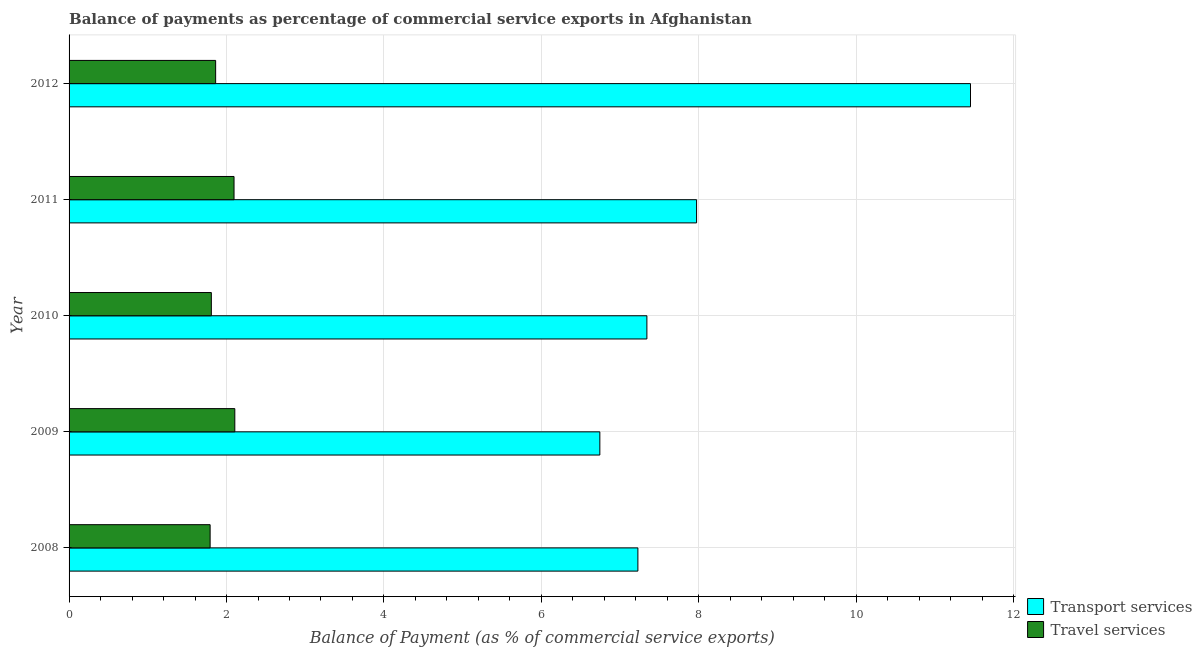How many different coloured bars are there?
Keep it short and to the point. 2. Are the number of bars per tick equal to the number of legend labels?
Provide a succinct answer. Yes. Are the number of bars on each tick of the Y-axis equal?
Provide a succinct answer. Yes. How many bars are there on the 3rd tick from the top?
Your response must be concise. 2. How many bars are there on the 1st tick from the bottom?
Your response must be concise. 2. In how many cases, is the number of bars for a given year not equal to the number of legend labels?
Offer a terse response. 0. What is the balance of payments of travel services in 2008?
Keep it short and to the point. 1.79. Across all years, what is the maximum balance of payments of transport services?
Ensure brevity in your answer.  11.45. Across all years, what is the minimum balance of payments of travel services?
Offer a very short reply. 1.79. In which year was the balance of payments of travel services maximum?
Your answer should be very brief. 2009. What is the total balance of payments of transport services in the graph?
Ensure brevity in your answer.  40.73. What is the difference between the balance of payments of travel services in 2010 and that in 2012?
Give a very brief answer. -0.06. What is the difference between the balance of payments of transport services in 2011 and the balance of payments of travel services in 2008?
Offer a very short reply. 6.18. What is the average balance of payments of travel services per year?
Provide a short and direct response. 1.93. In the year 2008, what is the difference between the balance of payments of travel services and balance of payments of transport services?
Your response must be concise. -5.43. In how many years, is the balance of payments of transport services greater than 5.2 %?
Your answer should be very brief. 5. What is the ratio of the balance of payments of transport services in 2009 to that in 2012?
Offer a very short reply. 0.59. What is the difference between the highest and the second highest balance of payments of transport services?
Offer a terse response. 3.48. What is the difference between the highest and the lowest balance of payments of travel services?
Ensure brevity in your answer.  0.31. What does the 2nd bar from the top in 2008 represents?
Give a very brief answer. Transport services. What does the 1st bar from the bottom in 2008 represents?
Offer a very short reply. Transport services. How many years are there in the graph?
Ensure brevity in your answer.  5. How are the legend labels stacked?
Your answer should be compact. Vertical. What is the title of the graph?
Offer a terse response. Balance of payments as percentage of commercial service exports in Afghanistan. What is the label or title of the X-axis?
Keep it short and to the point. Balance of Payment (as % of commercial service exports). What is the Balance of Payment (as % of commercial service exports) in Transport services in 2008?
Ensure brevity in your answer.  7.23. What is the Balance of Payment (as % of commercial service exports) in Travel services in 2008?
Provide a short and direct response. 1.79. What is the Balance of Payment (as % of commercial service exports) in Transport services in 2009?
Offer a very short reply. 6.74. What is the Balance of Payment (as % of commercial service exports) in Travel services in 2009?
Make the answer very short. 2.11. What is the Balance of Payment (as % of commercial service exports) of Transport services in 2010?
Provide a succinct answer. 7.34. What is the Balance of Payment (as % of commercial service exports) in Travel services in 2010?
Offer a very short reply. 1.81. What is the Balance of Payment (as % of commercial service exports) in Transport services in 2011?
Ensure brevity in your answer.  7.97. What is the Balance of Payment (as % of commercial service exports) of Travel services in 2011?
Ensure brevity in your answer.  2.1. What is the Balance of Payment (as % of commercial service exports) in Transport services in 2012?
Your answer should be compact. 11.45. What is the Balance of Payment (as % of commercial service exports) in Travel services in 2012?
Keep it short and to the point. 1.86. Across all years, what is the maximum Balance of Payment (as % of commercial service exports) in Transport services?
Provide a succinct answer. 11.45. Across all years, what is the maximum Balance of Payment (as % of commercial service exports) of Travel services?
Offer a terse response. 2.11. Across all years, what is the minimum Balance of Payment (as % of commercial service exports) of Transport services?
Ensure brevity in your answer.  6.74. Across all years, what is the minimum Balance of Payment (as % of commercial service exports) in Travel services?
Provide a short and direct response. 1.79. What is the total Balance of Payment (as % of commercial service exports) of Transport services in the graph?
Your answer should be very brief. 40.73. What is the total Balance of Payment (as % of commercial service exports) of Travel services in the graph?
Keep it short and to the point. 9.66. What is the difference between the Balance of Payment (as % of commercial service exports) of Transport services in 2008 and that in 2009?
Ensure brevity in your answer.  0.48. What is the difference between the Balance of Payment (as % of commercial service exports) in Travel services in 2008 and that in 2009?
Offer a terse response. -0.31. What is the difference between the Balance of Payment (as % of commercial service exports) of Transport services in 2008 and that in 2010?
Give a very brief answer. -0.11. What is the difference between the Balance of Payment (as % of commercial service exports) in Travel services in 2008 and that in 2010?
Your answer should be compact. -0.02. What is the difference between the Balance of Payment (as % of commercial service exports) in Transport services in 2008 and that in 2011?
Ensure brevity in your answer.  -0.75. What is the difference between the Balance of Payment (as % of commercial service exports) of Travel services in 2008 and that in 2011?
Provide a short and direct response. -0.3. What is the difference between the Balance of Payment (as % of commercial service exports) in Transport services in 2008 and that in 2012?
Provide a short and direct response. -4.23. What is the difference between the Balance of Payment (as % of commercial service exports) of Travel services in 2008 and that in 2012?
Provide a short and direct response. -0.07. What is the difference between the Balance of Payment (as % of commercial service exports) of Transport services in 2009 and that in 2010?
Your answer should be very brief. -0.6. What is the difference between the Balance of Payment (as % of commercial service exports) in Travel services in 2009 and that in 2010?
Your answer should be very brief. 0.3. What is the difference between the Balance of Payment (as % of commercial service exports) in Transport services in 2009 and that in 2011?
Offer a terse response. -1.23. What is the difference between the Balance of Payment (as % of commercial service exports) of Travel services in 2009 and that in 2011?
Make the answer very short. 0.01. What is the difference between the Balance of Payment (as % of commercial service exports) in Transport services in 2009 and that in 2012?
Your answer should be very brief. -4.71. What is the difference between the Balance of Payment (as % of commercial service exports) of Travel services in 2009 and that in 2012?
Give a very brief answer. 0.24. What is the difference between the Balance of Payment (as % of commercial service exports) in Transport services in 2010 and that in 2011?
Make the answer very short. -0.63. What is the difference between the Balance of Payment (as % of commercial service exports) of Travel services in 2010 and that in 2011?
Offer a very short reply. -0.29. What is the difference between the Balance of Payment (as % of commercial service exports) in Transport services in 2010 and that in 2012?
Your answer should be compact. -4.11. What is the difference between the Balance of Payment (as % of commercial service exports) of Travel services in 2010 and that in 2012?
Your answer should be very brief. -0.05. What is the difference between the Balance of Payment (as % of commercial service exports) of Transport services in 2011 and that in 2012?
Offer a very short reply. -3.48. What is the difference between the Balance of Payment (as % of commercial service exports) in Travel services in 2011 and that in 2012?
Provide a short and direct response. 0.23. What is the difference between the Balance of Payment (as % of commercial service exports) in Transport services in 2008 and the Balance of Payment (as % of commercial service exports) in Travel services in 2009?
Make the answer very short. 5.12. What is the difference between the Balance of Payment (as % of commercial service exports) of Transport services in 2008 and the Balance of Payment (as % of commercial service exports) of Travel services in 2010?
Your answer should be compact. 5.42. What is the difference between the Balance of Payment (as % of commercial service exports) in Transport services in 2008 and the Balance of Payment (as % of commercial service exports) in Travel services in 2011?
Offer a very short reply. 5.13. What is the difference between the Balance of Payment (as % of commercial service exports) in Transport services in 2008 and the Balance of Payment (as % of commercial service exports) in Travel services in 2012?
Provide a succinct answer. 5.36. What is the difference between the Balance of Payment (as % of commercial service exports) in Transport services in 2009 and the Balance of Payment (as % of commercial service exports) in Travel services in 2010?
Your answer should be compact. 4.93. What is the difference between the Balance of Payment (as % of commercial service exports) in Transport services in 2009 and the Balance of Payment (as % of commercial service exports) in Travel services in 2011?
Make the answer very short. 4.65. What is the difference between the Balance of Payment (as % of commercial service exports) in Transport services in 2009 and the Balance of Payment (as % of commercial service exports) in Travel services in 2012?
Keep it short and to the point. 4.88. What is the difference between the Balance of Payment (as % of commercial service exports) of Transport services in 2010 and the Balance of Payment (as % of commercial service exports) of Travel services in 2011?
Your answer should be very brief. 5.24. What is the difference between the Balance of Payment (as % of commercial service exports) in Transport services in 2010 and the Balance of Payment (as % of commercial service exports) in Travel services in 2012?
Keep it short and to the point. 5.48. What is the difference between the Balance of Payment (as % of commercial service exports) of Transport services in 2011 and the Balance of Payment (as % of commercial service exports) of Travel services in 2012?
Offer a terse response. 6.11. What is the average Balance of Payment (as % of commercial service exports) in Transport services per year?
Your answer should be very brief. 8.15. What is the average Balance of Payment (as % of commercial service exports) of Travel services per year?
Ensure brevity in your answer.  1.93. In the year 2008, what is the difference between the Balance of Payment (as % of commercial service exports) of Transport services and Balance of Payment (as % of commercial service exports) of Travel services?
Offer a very short reply. 5.43. In the year 2009, what is the difference between the Balance of Payment (as % of commercial service exports) in Transport services and Balance of Payment (as % of commercial service exports) in Travel services?
Keep it short and to the point. 4.64. In the year 2010, what is the difference between the Balance of Payment (as % of commercial service exports) in Transport services and Balance of Payment (as % of commercial service exports) in Travel services?
Ensure brevity in your answer.  5.53. In the year 2011, what is the difference between the Balance of Payment (as % of commercial service exports) in Transport services and Balance of Payment (as % of commercial service exports) in Travel services?
Offer a terse response. 5.88. In the year 2012, what is the difference between the Balance of Payment (as % of commercial service exports) in Transport services and Balance of Payment (as % of commercial service exports) in Travel services?
Give a very brief answer. 9.59. What is the ratio of the Balance of Payment (as % of commercial service exports) of Transport services in 2008 to that in 2009?
Your answer should be very brief. 1.07. What is the ratio of the Balance of Payment (as % of commercial service exports) of Travel services in 2008 to that in 2009?
Your response must be concise. 0.85. What is the ratio of the Balance of Payment (as % of commercial service exports) of Transport services in 2008 to that in 2010?
Keep it short and to the point. 0.98. What is the ratio of the Balance of Payment (as % of commercial service exports) of Travel services in 2008 to that in 2010?
Provide a short and direct response. 0.99. What is the ratio of the Balance of Payment (as % of commercial service exports) of Transport services in 2008 to that in 2011?
Keep it short and to the point. 0.91. What is the ratio of the Balance of Payment (as % of commercial service exports) of Travel services in 2008 to that in 2011?
Give a very brief answer. 0.86. What is the ratio of the Balance of Payment (as % of commercial service exports) in Transport services in 2008 to that in 2012?
Give a very brief answer. 0.63. What is the ratio of the Balance of Payment (as % of commercial service exports) of Travel services in 2008 to that in 2012?
Make the answer very short. 0.96. What is the ratio of the Balance of Payment (as % of commercial service exports) of Transport services in 2009 to that in 2010?
Make the answer very short. 0.92. What is the ratio of the Balance of Payment (as % of commercial service exports) of Travel services in 2009 to that in 2010?
Offer a very short reply. 1.16. What is the ratio of the Balance of Payment (as % of commercial service exports) in Transport services in 2009 to that in 2011?
Provide a short and direct response. 0.85. What is the ratio of the Balance of Payment (as % of commercial service exports) in Travel services in 2009 to that in 2011?
Your answer should be compact. 1. What is the ratio of the Balance of Payment (as % of commercial service exports) of Transport services in 2009 to that in 2012?
Your answer should be compact. 0.59. What is the ratio of the Balance of Payment (as % of commercial service exports) of Travel services in 2009 to that in 2012?
Keep it short and to the point. 1.13. What is the ratio of the Balance of Payment (as % of commercial service exports) in Transport services in 2010 to that in 2011?
Give a very brief answer. 0.92. What is the ratio of the Balance of Payment (as % of commercial service exports) in Travel services in 2010 to that in 2011?
Offer a very short reply. 0.86. What is the ratio of the Balance of Payment (as % of commercial service exports) in Transport services in 2010 to that in 2012?
Offer a terse response. 0.64. What is the ratio of the Balance of Payment (as % of commercial service exports) of Travel services in 2010 to that in 2012?
Your answer should be compact. 0.97. What is the ratio of the Balance of Payment (as % of commercial service exports) in Transport services in 2011 to that in 2012?
Keep it short and to the point. 0.7. What is the ratio of the Balance of Payment (as % of commercial service exports) in Travel services in 2011 to that in 2012?
Provide a short and direct response. 1.13. What is the difference between the highest and the second highest Balance of Payment (as % of commercial service exports) of Transport services?
Make the answer very short. 3.48. What is the difference between the highest and the second highest Balance of Payment (as % of commercial service exports) in Travel services?
Your answer should be compact. 0.01. What is the difference between the highest and the lowest Balance of Payment (as % of commercial service exports) in Transport services?
Give a very brief answer. 4.71. What is the difference between the highest and the lowest Balance of Payment (as % of commercial service exports) of Travel services?
Make the answer very short. 0.31. 